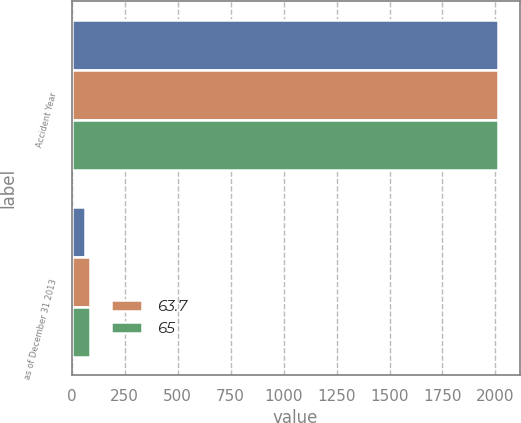<chart> <loc_0><loc_0><loc_500><loc_500><stacked_bar_chart><ecel><fcel>Accident Year<fcel>as of December 31 2013<nl><fcel>nan<fcel>2013<fcel>64<nl><fcel>63.7<fcel>2011<fcel>88<nl><fcel>65<fcel>2011<fcel>85.9<nl></chart> 